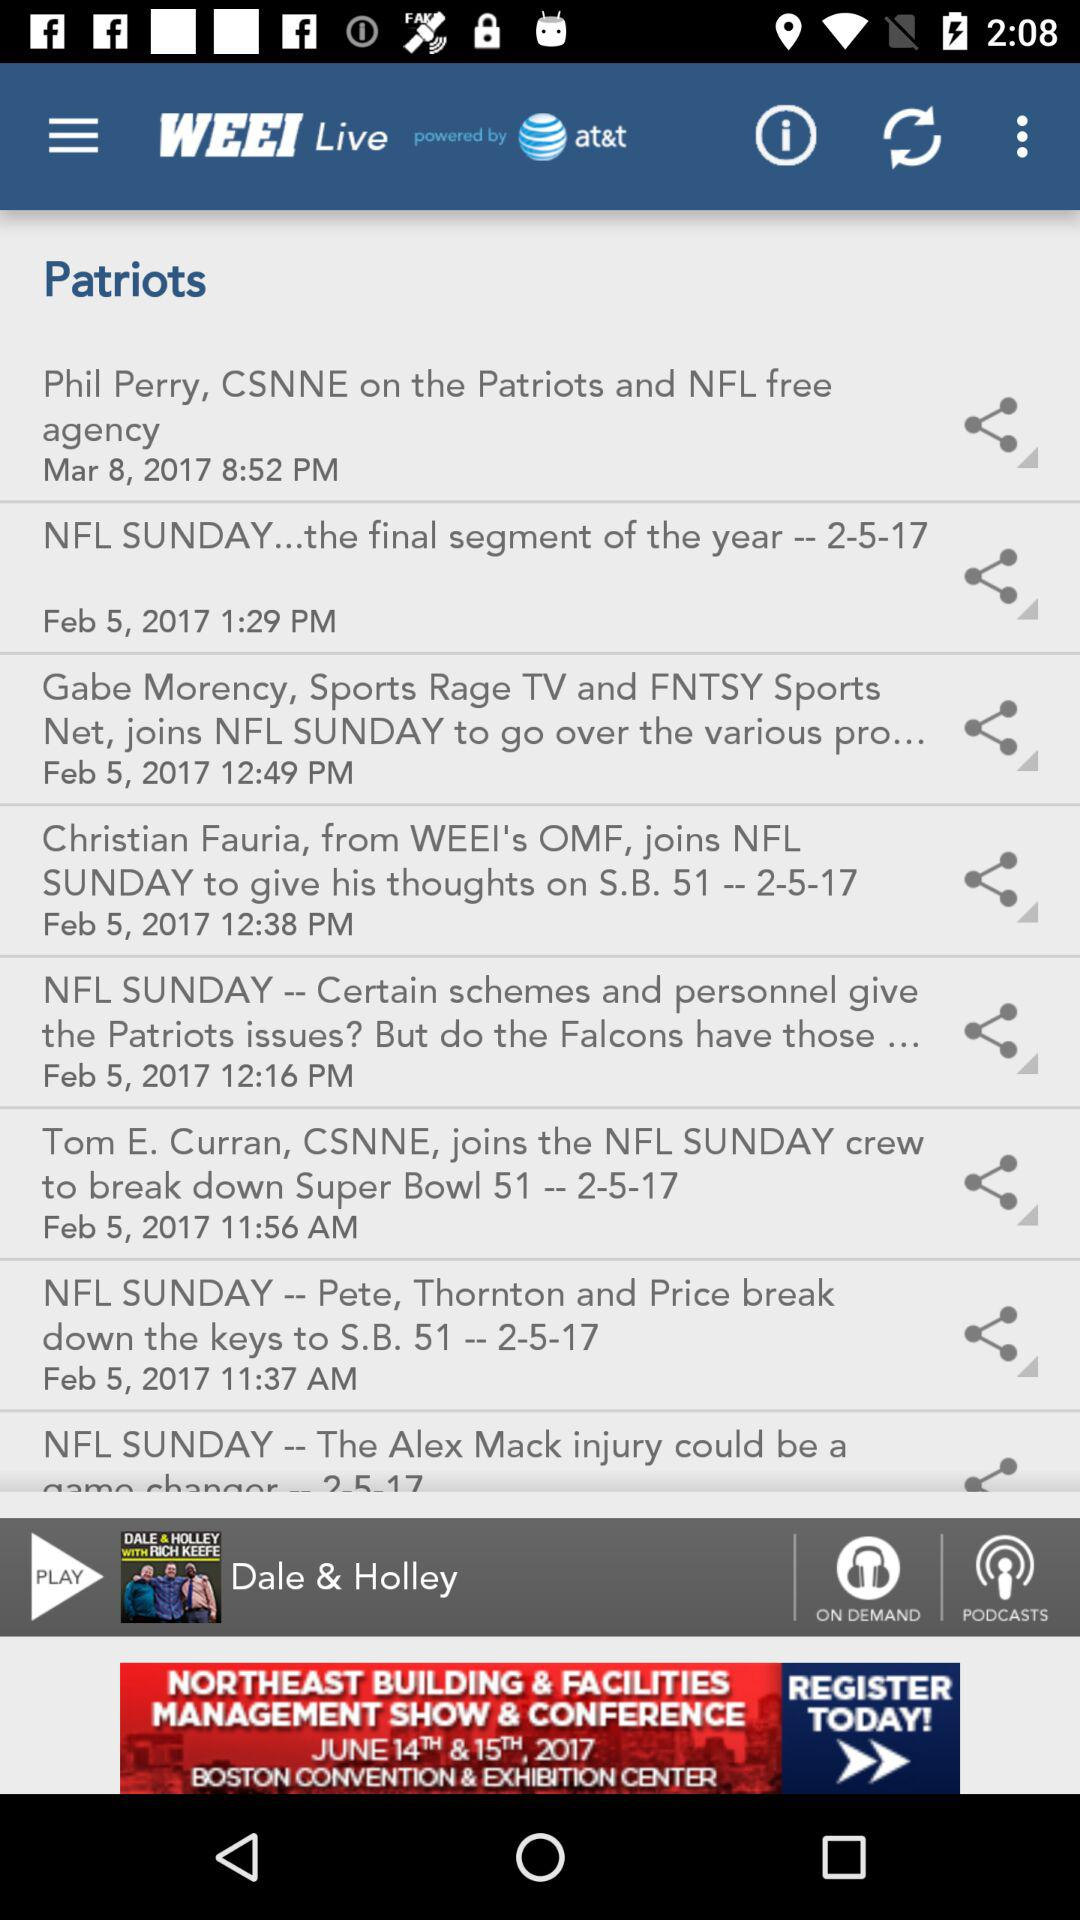At what time is the post "Phil Perry, CSNNE" updated? The time is 8:52 PM. 